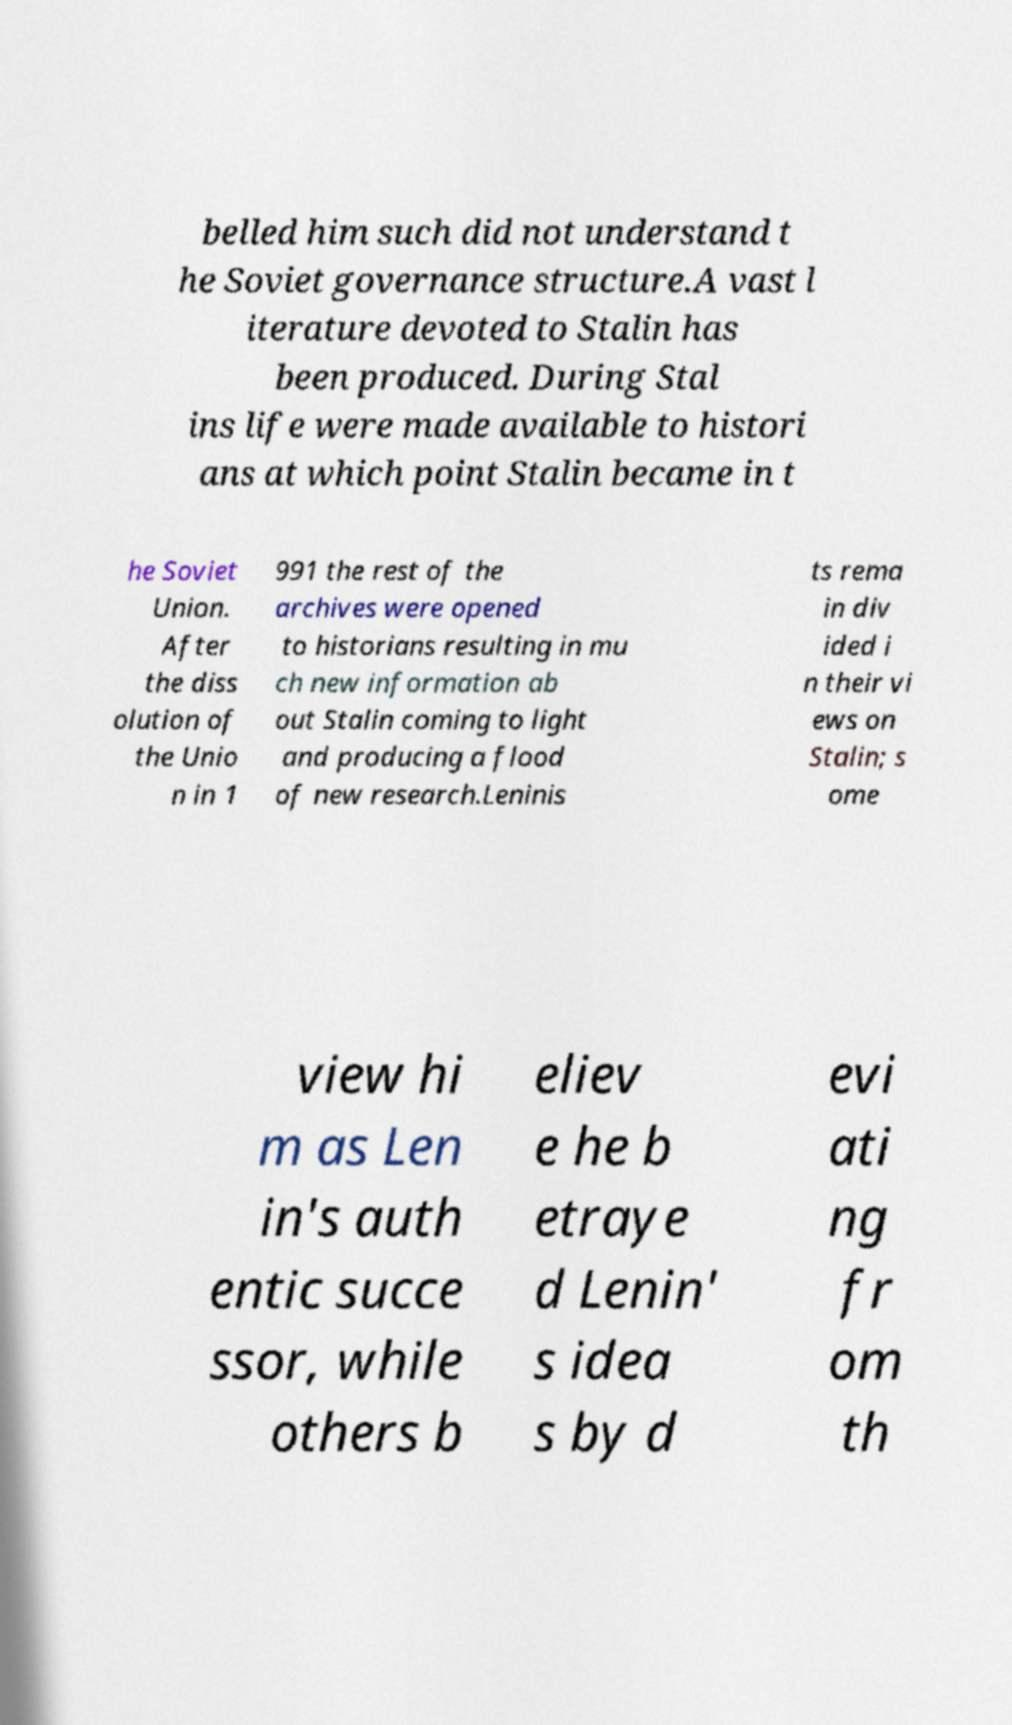Could you assist in decoding the text presented in this image and type it out clearly? belled him such did not understand t he Soviet governance structure.A vast l iterature devoted to Stalin has been produced. During Stal ins life were made available to histori ans at which point Stalin became in t he Soviet Union. After the diss olution of the Unio n in 1 991 the rest of the archives were opened to historians resulting in mu ch new information ab out Stalin coming to light and producing a flood of new research.Leninis ts rema in div ided i n their vi ews on Stalin; s ome view hi m as Len in's auth entic succe ssor, while others b eliev e he b etraye d Lenin' s idea s by d evi ati ng fr om th 